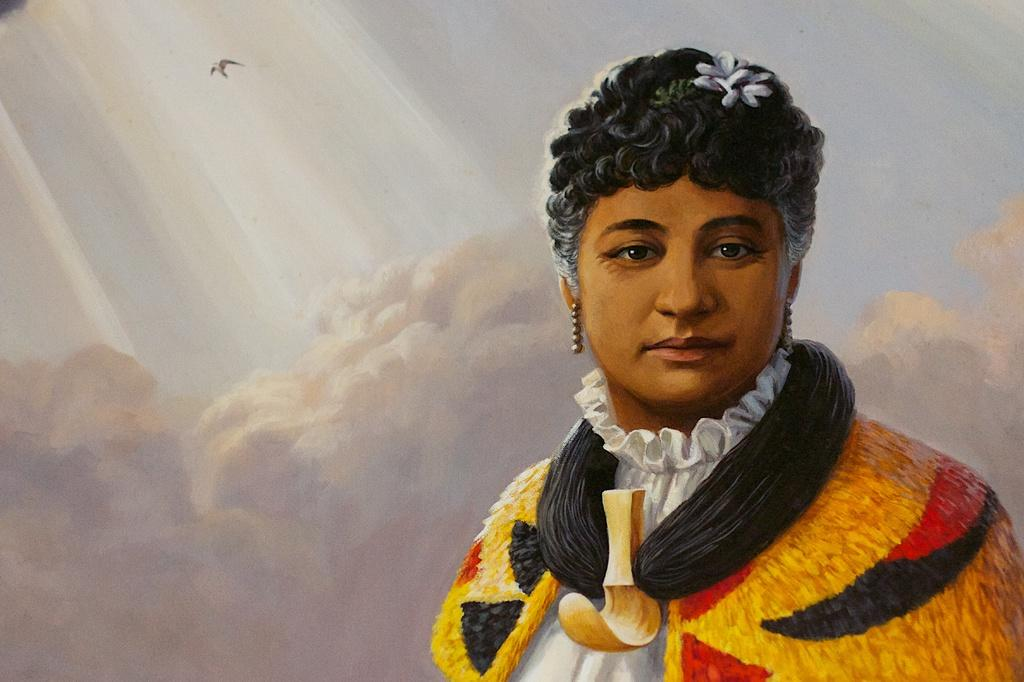What type of artwork is shown in the image? The image is a painting. Who or what is the main subject of the painting? The painting depicts a woman. What is visible in the background of the painting? There are clouds behind the woman in the painting. Are there any animals present in the painting? Yes, a bird is flying in the sky in the painting. What type of bead is being used to create the woman's hair in the painting? There is no bead present in the painting; the woman's hair is depicted using paint. What type of food is being served on the table in the painting? There is no table or food present in the painting; it only depicts a woman, clouds, and a bird. 